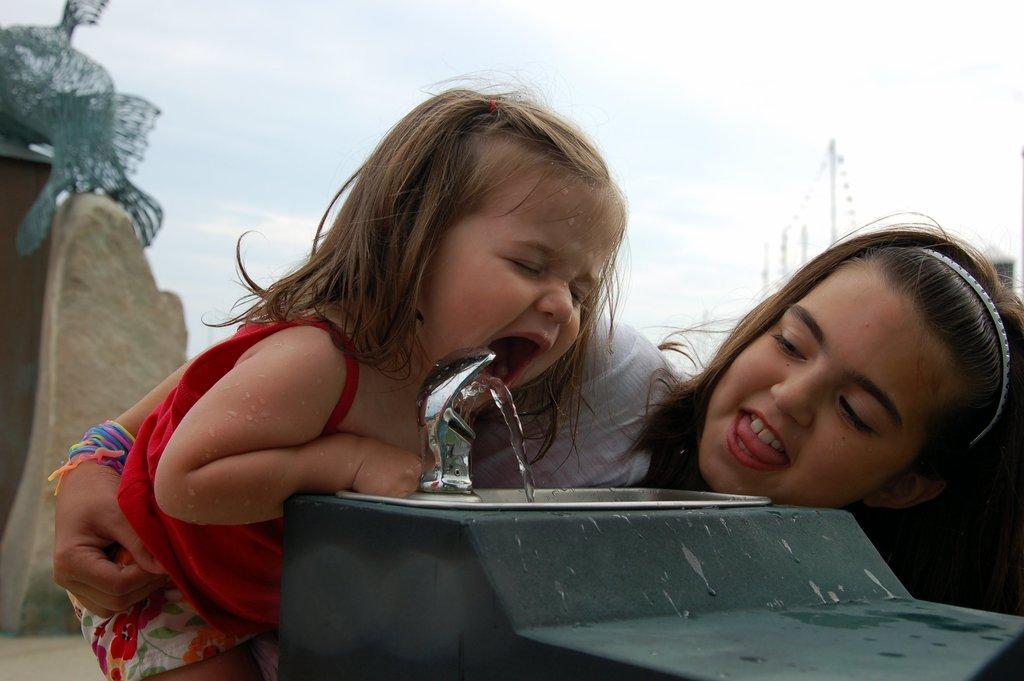How would you summarize this image in a sentence or two? This image consists of a wash basin. In the front, we can see two persons. On the left, the kid wearing a red dress is drinking water. In the background, there is a sky. On the left, we can see a rock. 